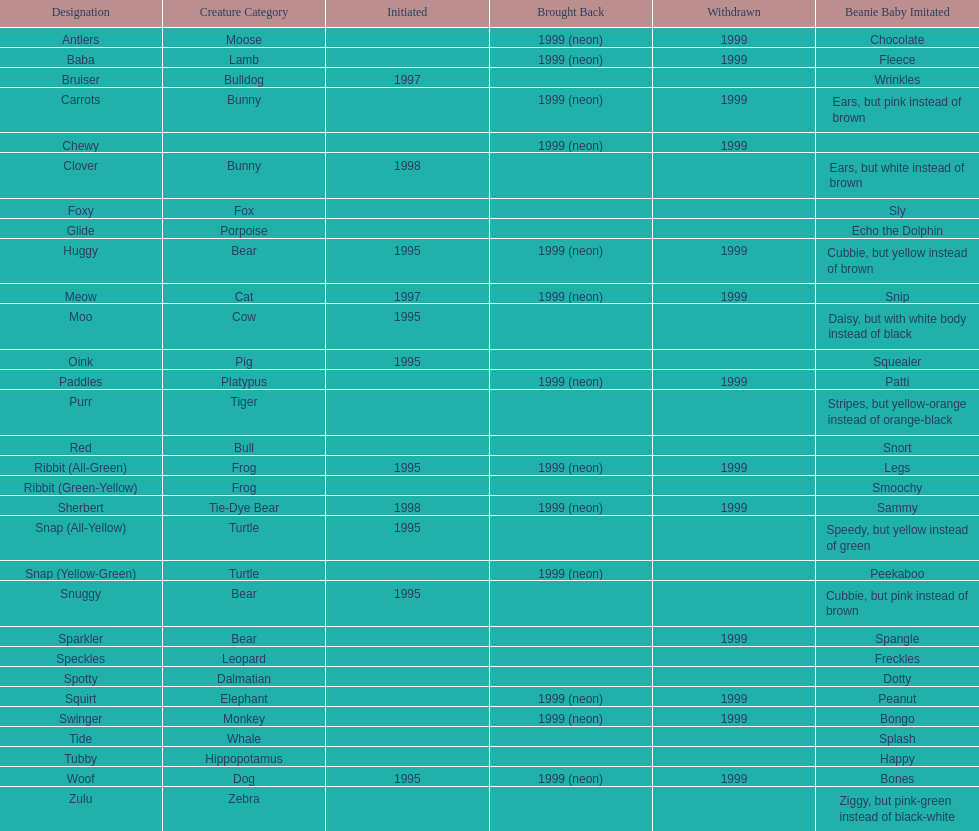What is the name of the last pillow pal on this chart? Zulu. 